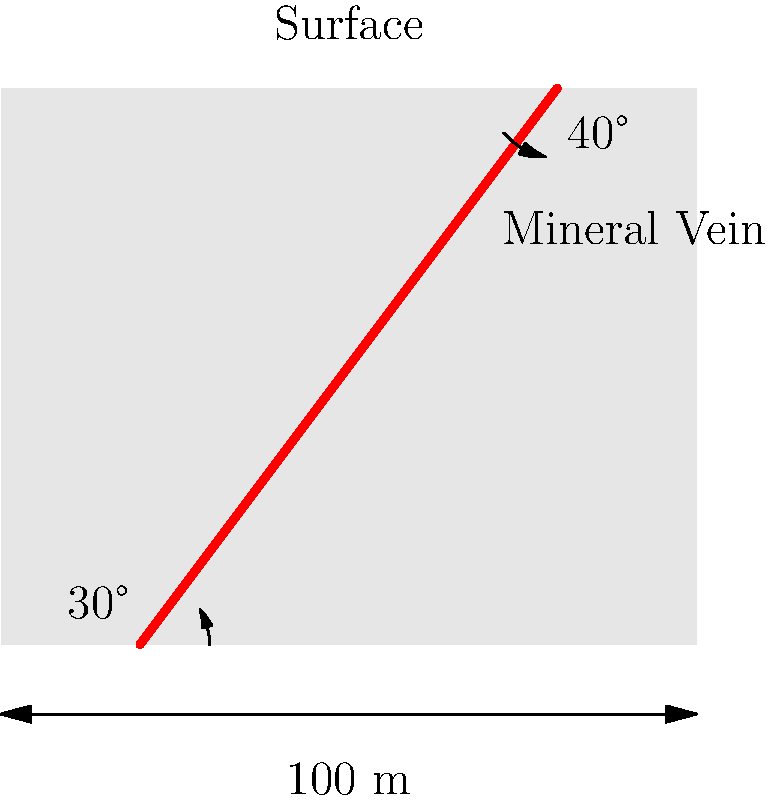In the cross-sectional diagram of a mineral vein near the Lueshe mine, the vein is shown entering the ground at a 30° angle and exiting at a 40° angle. If the horizontal distance between these two points is 100 meters, estimate the length of the mineral vein visible in this cross-section. Round your answer to the nearest meter. To estimate the length of the mineral vein, we can follow these steps:

1. Recognize that the mineral vein forms a curved path, which we can approximate as an arc of a circle.

2. To find the radius of this circular arc, we need to use the angle formed at the center of the circle. This angle is the sum of the entry and exit angles: 30° + 40° = 70°.

3. The central angle of the arc is the supplementary angle to 70°, which is 180° - 70° = 110°.

4. We can use the formula for the chord length of a circular arc:
   $c = 2R \sin(\frac{\theta}{2})$
   Where $c$ is the chord length (100 m in this case), $R$ is the radius, and $\theta$ is the central angle in radians.

5. Convert 110° to radians: $\frac{110 \pi}{180} \approx 1.92$ radians

6. Substitute into the formula:
   $100 = 2R \sin(\frac{1.92}{2})$

7. Solve for $R$:
   $R = \frac{100}{2 \sin(0.96)} \approx 60.86$ meters

8. Now that we have the radius, we can calculate the arc length using the formula:
   $L = R\theta$
   Where $L$ is the arc length, $R$ is the radius, and $\theta$ is the central angle in radians.

9. Substitute the values:
   $L = 60.86 \times 1.92 \approx 116.85$ meters

10. Rounding to the nearest meter, we get 117 meters.
Answer: 117 meters 